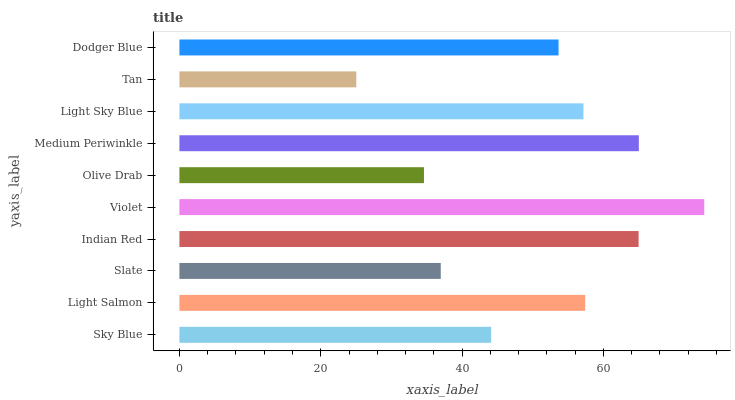Is Tan the minimum?
Answer yes or no. Yes. Is Violet the maximum?
Answer yes or no. Yes. Is Light Salmon the minimum?
Answer yes or no. No. Is Light Salmon the maximum?
Answer yes or no. No. Is Light Salmon greater than Sky Blue?
Answer yes or no. Yes. Is Sky Blue less than Light Salmon?
Answer yes or no. Yes. Is Sky Blue greater than Light Salmon?
Answer yes or no. No. Is Light Salmon less than Sky Blue?
Answer yes or no. No. Is Light Sky Blue the high median?
Answer yes or no. Yes. Is Dodger Blue the low median?
Answer yes or no. Yes. Is Dodger Blue the high median?
Answer yes or no. No. Is Slate the low median?
Answer yes or no. No. 